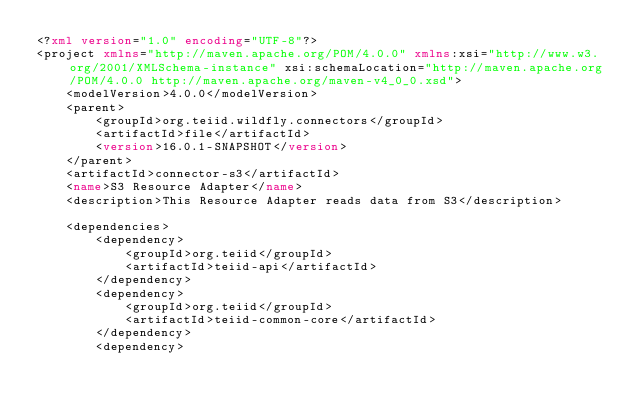<code> <loc_0><loc_0><loc_500><loc_500><_XML_><?xml version="1.0" encoding="UTF-8"?>
<project xmlns="http://maven.apache.org/POM/4.0.0" xmlns:xsi="http://www.w3.org/2001/XMLSchema-instance" xsi:schemaLocation="http://maven.apache.org/POM/4.0.0 http://maven.apache.org/maven-v4_0_0.xsd">
    <modelVersion>4.0.0</modelVersion> 
    <parent>
        <groupId>org.teiid.wildfly.connectors</groupId>
        <artifactId>file</artifactId>
        <version>16.0.1-SNAPSHOT</version>
    </parent>
    <artifactId>connector-s3</artifactId>
    <name>S3 Resource Adapter</name>
    <description>This Resource Adapter reads data from S3</description>
    
    <dependencies>
        <dependency>
            <groupId>org.teiid</groupId>
            <artifactId>teiid-api</artifactId>
        </dependency>
        <dependency>
            <groupId>org.teiid</groupId>
            <artifactId>teiid-common-core</artifactId>
        </dependency>
        <dependency></code> 